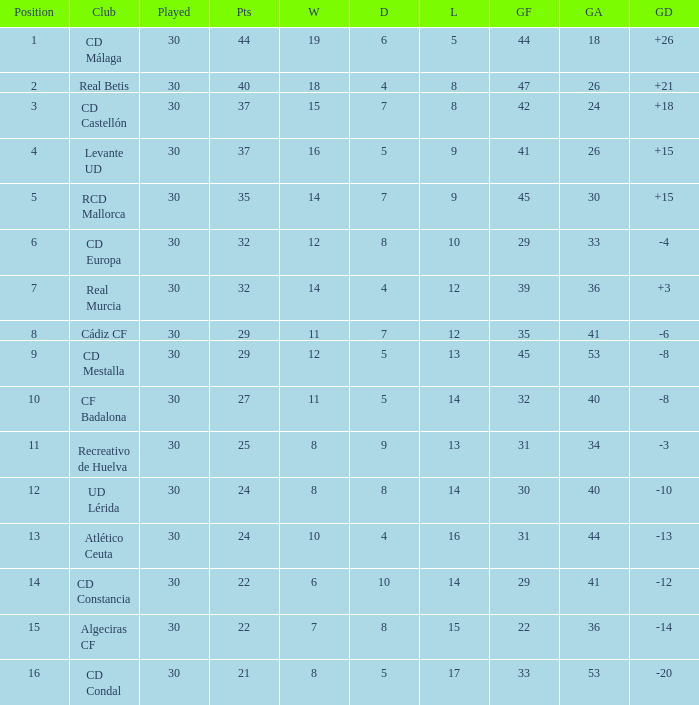What is the number of wins when the goals against is larger than 41, points is 29, and draws are larger than 5? 0.0. 